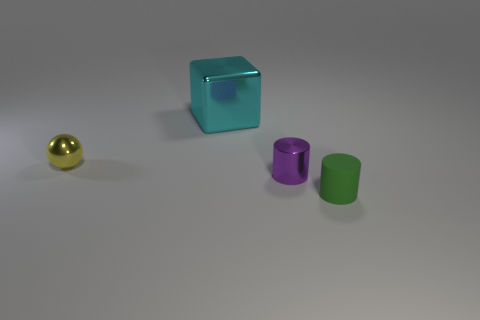What textures can be observed on the objects and what does that say about the material they're made of? The objects in the image have smooth and reflective surfaces, suggesting they are likely made of materials like polished metal or plastic, which are commonly used for their sleek appearance and ease of manufacturing. 